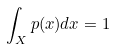Convert formula to latex. <formula><loc_0><loc_0><loc_500><loc_500>\int _ { X } p ( x ) d x = 1</formula> 